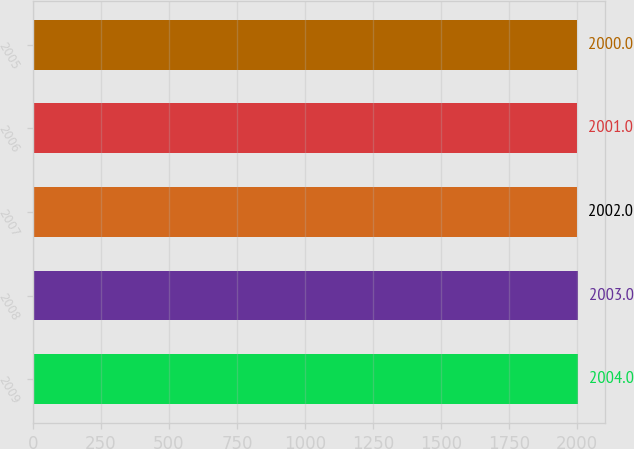<chart> <loc_0><loc_0><loc_500><loc_500><bar_chart><fcel>2009<fcel>2008<fcel>2007<fcel>2006<fcel>2005<nl><fcel>2004<fcel>2003<fcel>2002<fcel>2001<fcel>2000<nl></chart> 